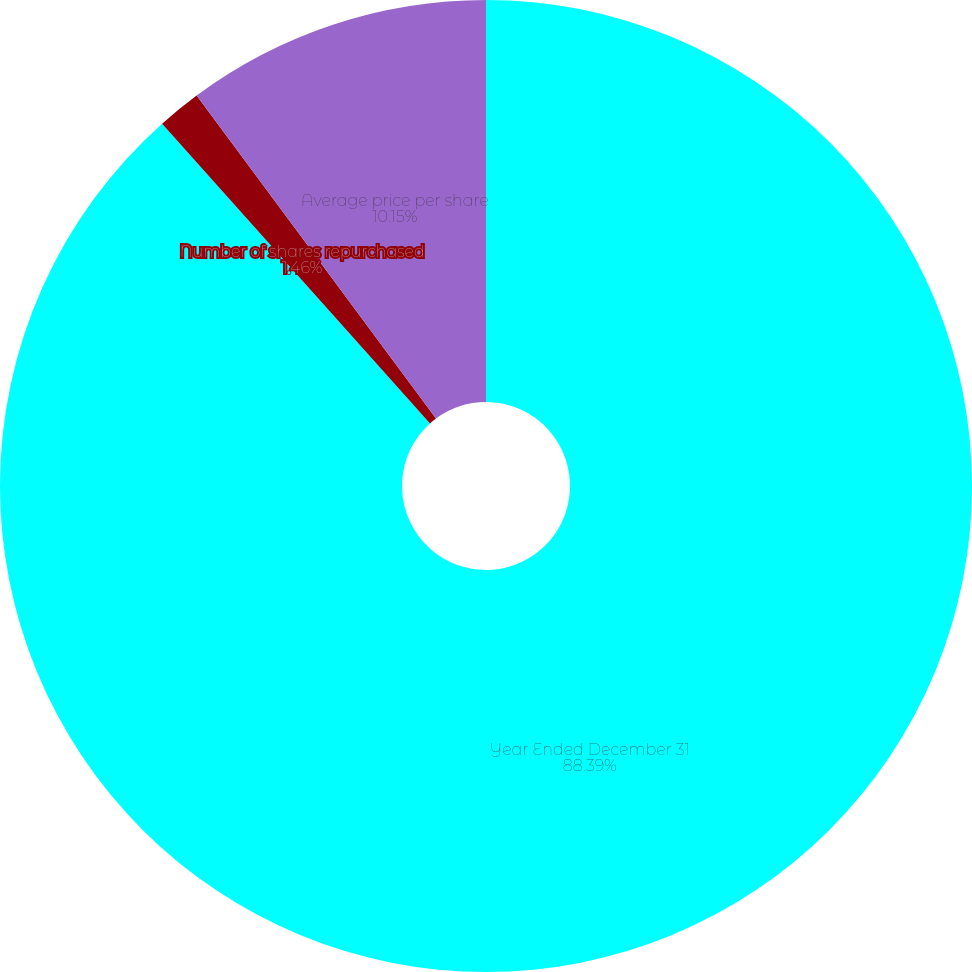Convert chart. <chart><loc_0><loc_0><loc_500><loc_500><pie_chart><fcel>Year Ended December 31<fcel>Number of shares repurchased<fcel>Average price per share<nl><fcel>88.39%<fcel>1.46%<fcel>10.15%<nl></chart> 